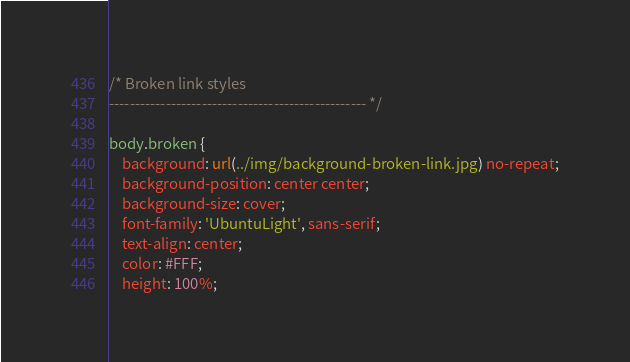Convert code to text. <code><loc_0><loc_0><loc_500><loc_500><_CSS_>/* Broken link styles
-------------------------------------------------- */

body.broken {
	background: url(../img/background-broken-link.jpg) no-repeat;
	background-position: center center;
	background-size: cover;
	font-family: 'UbuntuLight', sans-serif;
	text-align: center;
	color: #FFF;
	height: 100%;</code> 